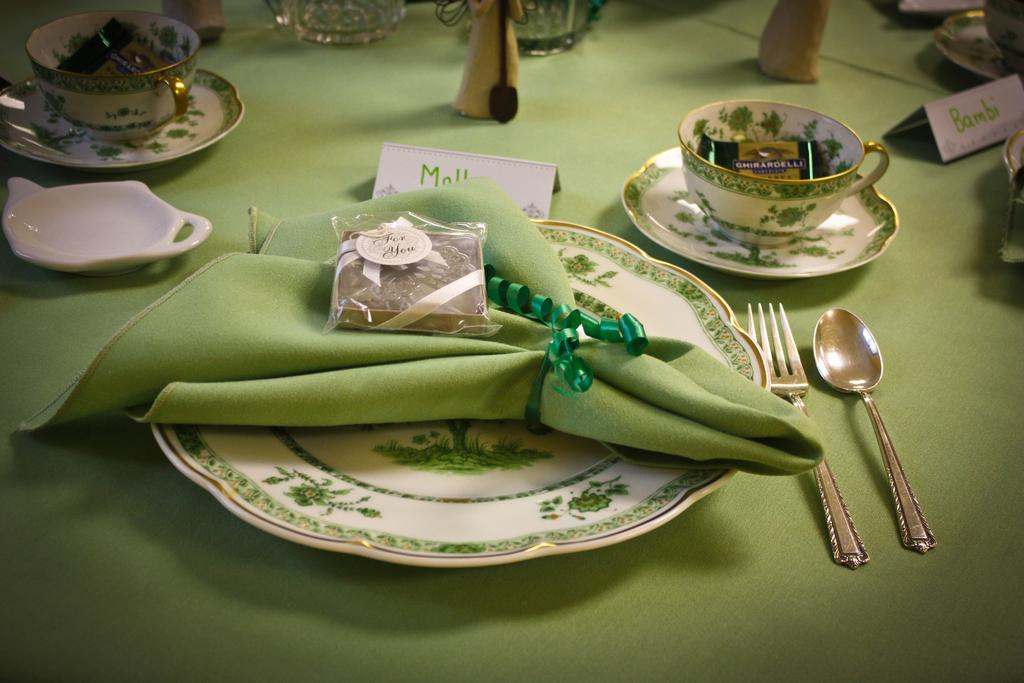What is on the plate in the image? A cloth and a chocolate packet are on the plate in the image. What is inside the chocolate packet? The chocolate packet contains chocolate. What is in the cup in the image? There is a chocolate in the cup. What utensils are present in the image? There is a spoon and a fork in the image. How many dolls are visible in the image? There are no dolls present in the image. Is there a camera visible in the image? There is no camera present in the image. 